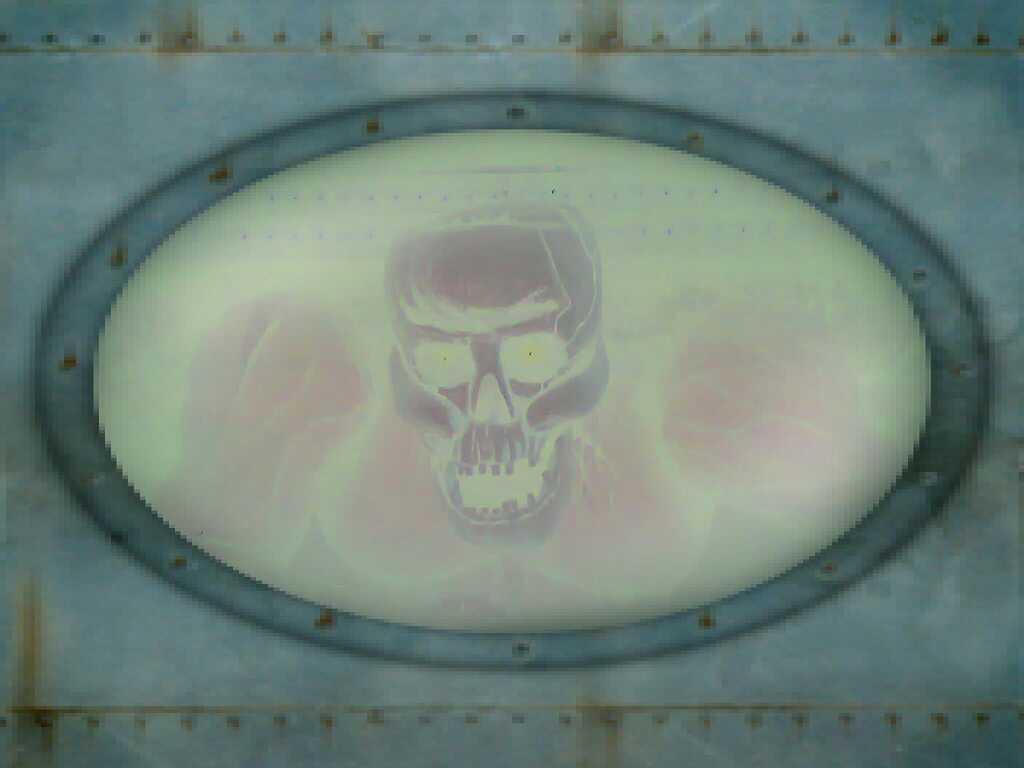What is the person in the image holding? The person is holding a camera. What can be seen in the background of the image? There is a building in the background of the image. Is there any furniture or other objects present in the image? No specific furniture or objects are mentioned, but there is a building in the background. What time is displayed on the clock in the image? There is no clock present in the image. --- Facts: 1. There is a person in the image. 2. The person is holding a book. 3. There is a table in the background of the image. Absurd Topics: hydrant, north, clock Conversation: What is the person in the image holding? The person is holding a book. What can be seen in the background of the image? There is a table in the background of the image. Is there any furniture or other objects present in the image? No specific furniture or objects are mentioned, but there is a table in the background. Reasoning: Let's think step by step in order to produce the conversation. We start by identifying the main subject in the image, which is the person holding a book. Then, we expand the conversation to include the background of the image, which features a table. We avoid mentioning any specific furniture or objects, as they are not mentioned in the provided facts. Absurd Question/Answer: What direction is the hydrant facing in the image? There is no hydrant present in the image. --- Facts: 1. There is a person in the image. 2. The person is holding a phone. 3. There is a chair in the background of the image. Absurd Topics: hydrant, north, clock Conversation: What is the person in the image holding? The person is holding a phone. What can be seen in the background of the image? There is a chair in the background of the image. Is there any furniture or other objects present in the image? No specific furniture or objects are mentioned, but there is a chair in the background. Reasoning: Let's think step by step in order to produce the conversation. We start by identifying the main subject in the image, which is the person holding a phone. Then, we expand the conversation to include the background of the image, which features a chair. We avoid mentioning any specific furniture or objects, as they are not mentioned in the provided facts. Absurd Question/Answer: What time is displayed on the clock in the image? There is no clock present in the image. --- Facts: 1. There is a person in the image. 2. The person is holding a laptop. 3. There is a desk in the background of the image. Absurd Topics: hydrant, north, clock Conversation: 